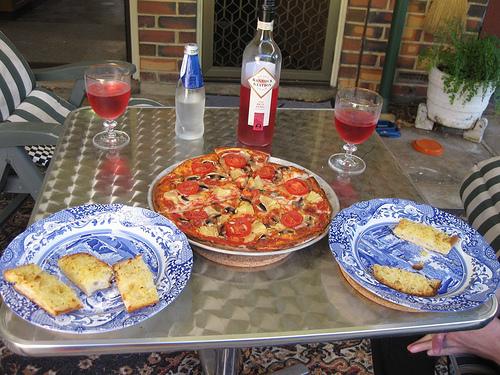WHAT COST 15.00?
Give a very brief answer. Pizza. Is that a petunia plant in the back?
Answer briefly. No. What color is the cap on the water bottle on the left side of the picture?
Answer briefly. White. Is the table  metal?
Short answer required. Yes. What color is the wine?
Quick response, please. Red. 